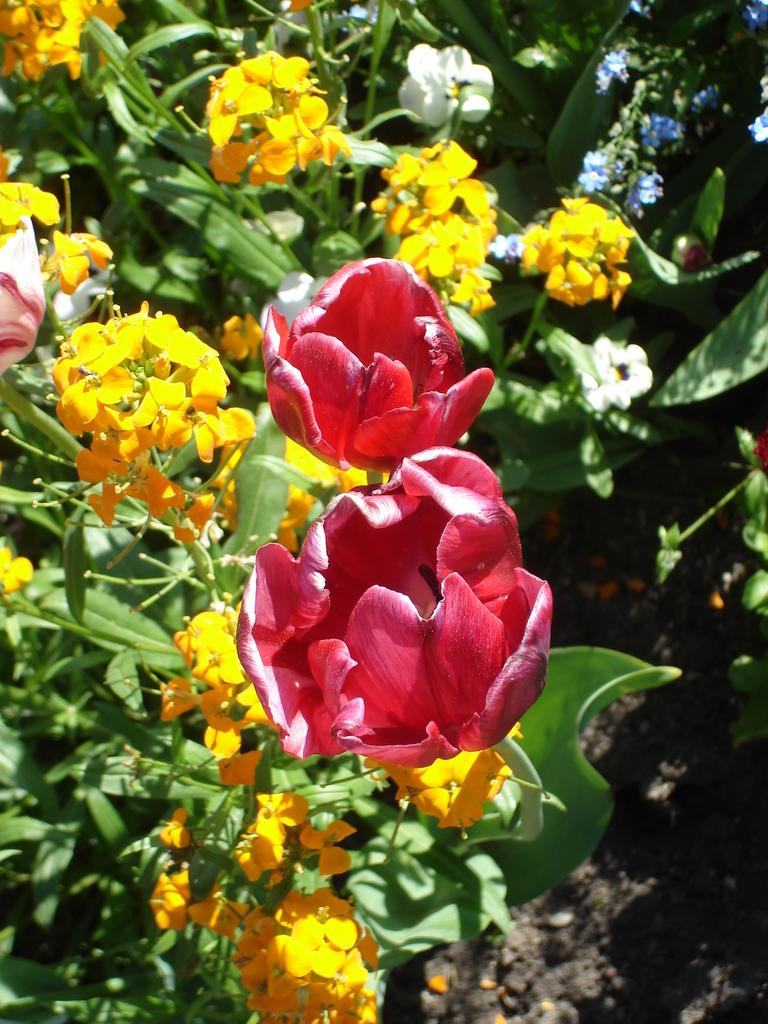What types of plants can be seen in the image? There are plants with flowers and plants with leaves in the image. Can you describe the plants in the background of the image? The background of the image includes plants on the land. How many oranges are hanging from the trees in the image? There are no trees or oranges present in the image. 